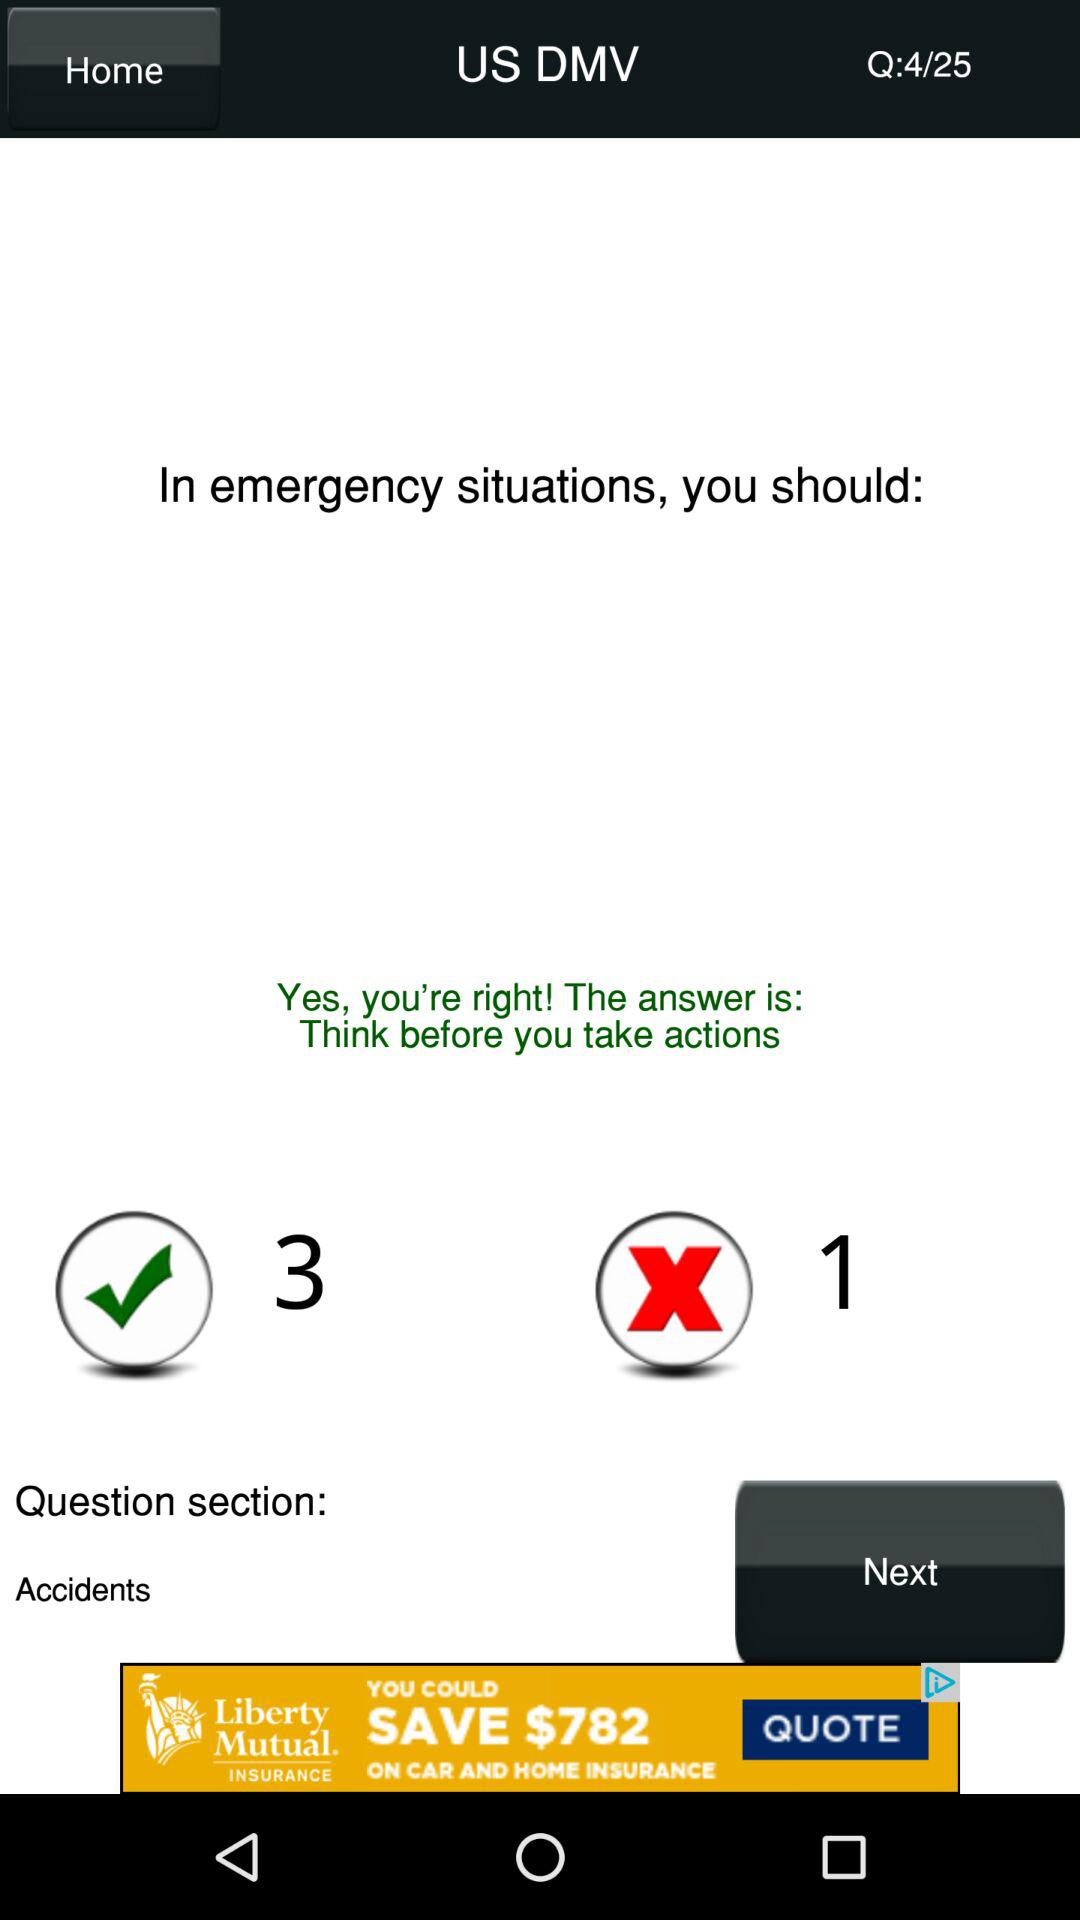What is the current question number shown on the screen? The current question number is 4. 